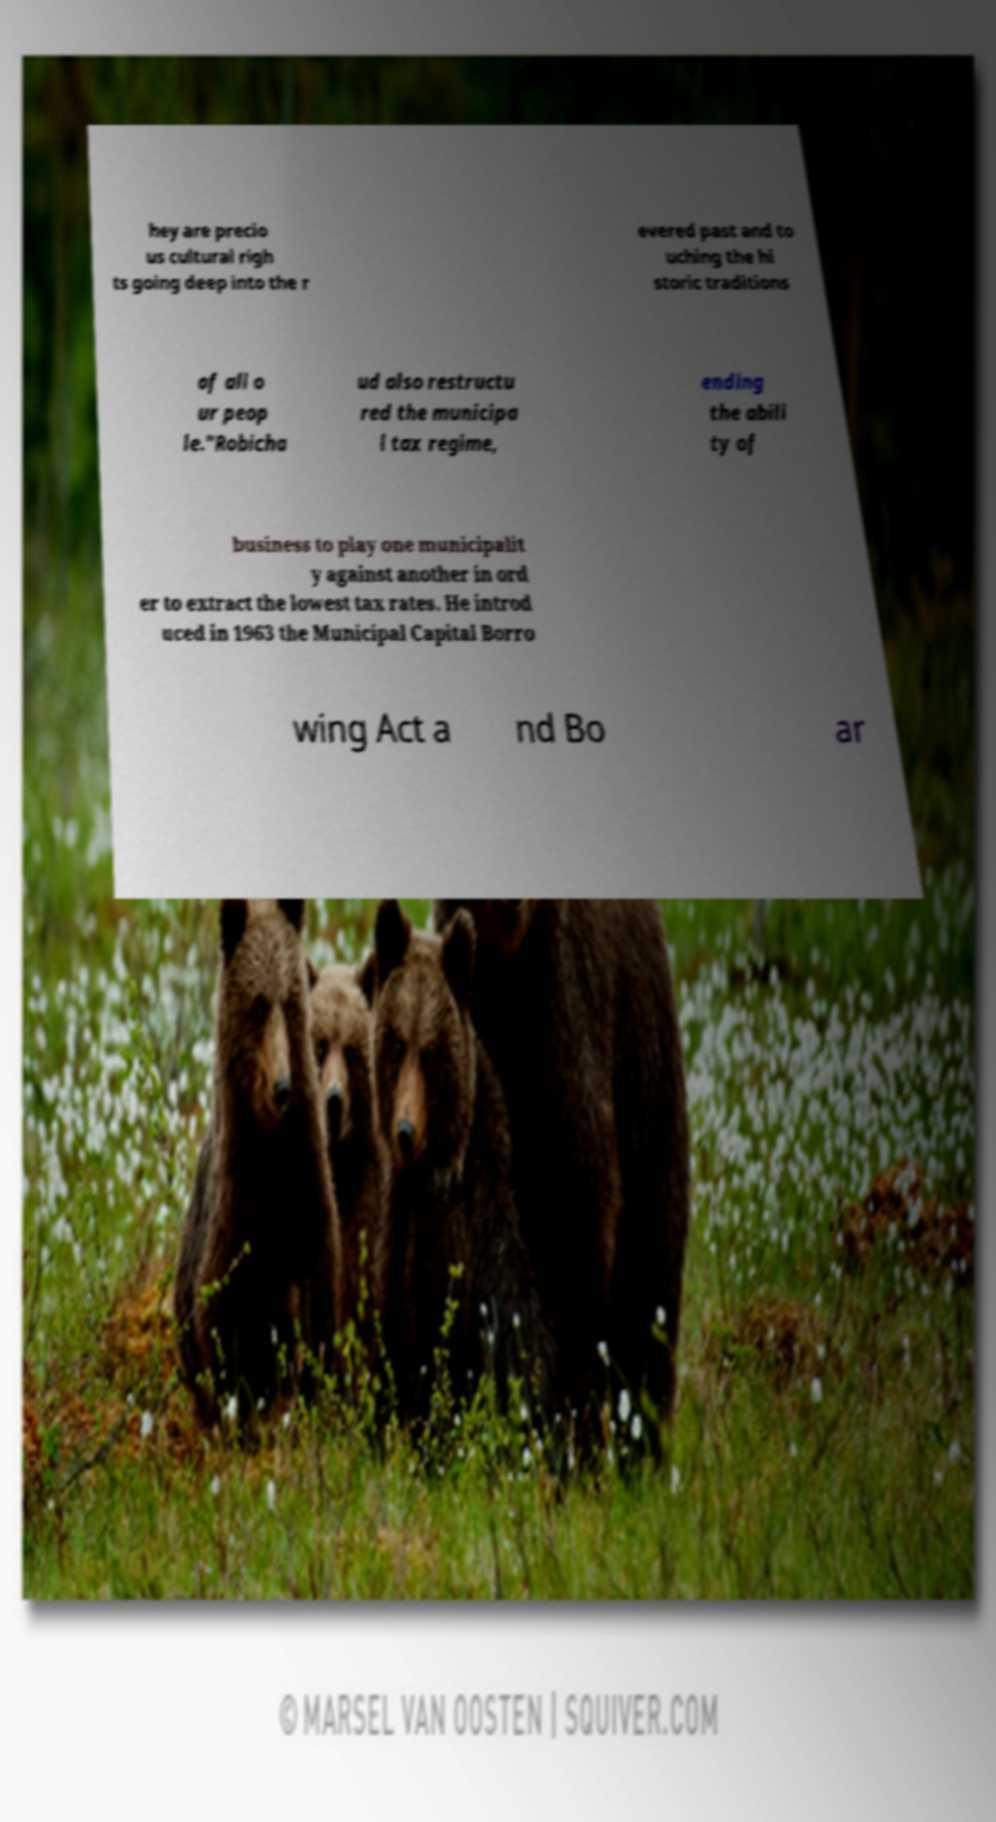There's text embedded in this image that I need extracted. Can you transcribe it verbatim? hey are precio us cultural righ ts going deep into the r evered past and to uching the hi storic traditions of all o ur peop le."Robicha ud also restructu red the municipa l tax regime, ending the abili ty of business to play one municipalit y against another in ord er to extract the lowest tax rates. He introd uced in 1963 the Municipal Capital Borro wing Act a nd Bo ar 